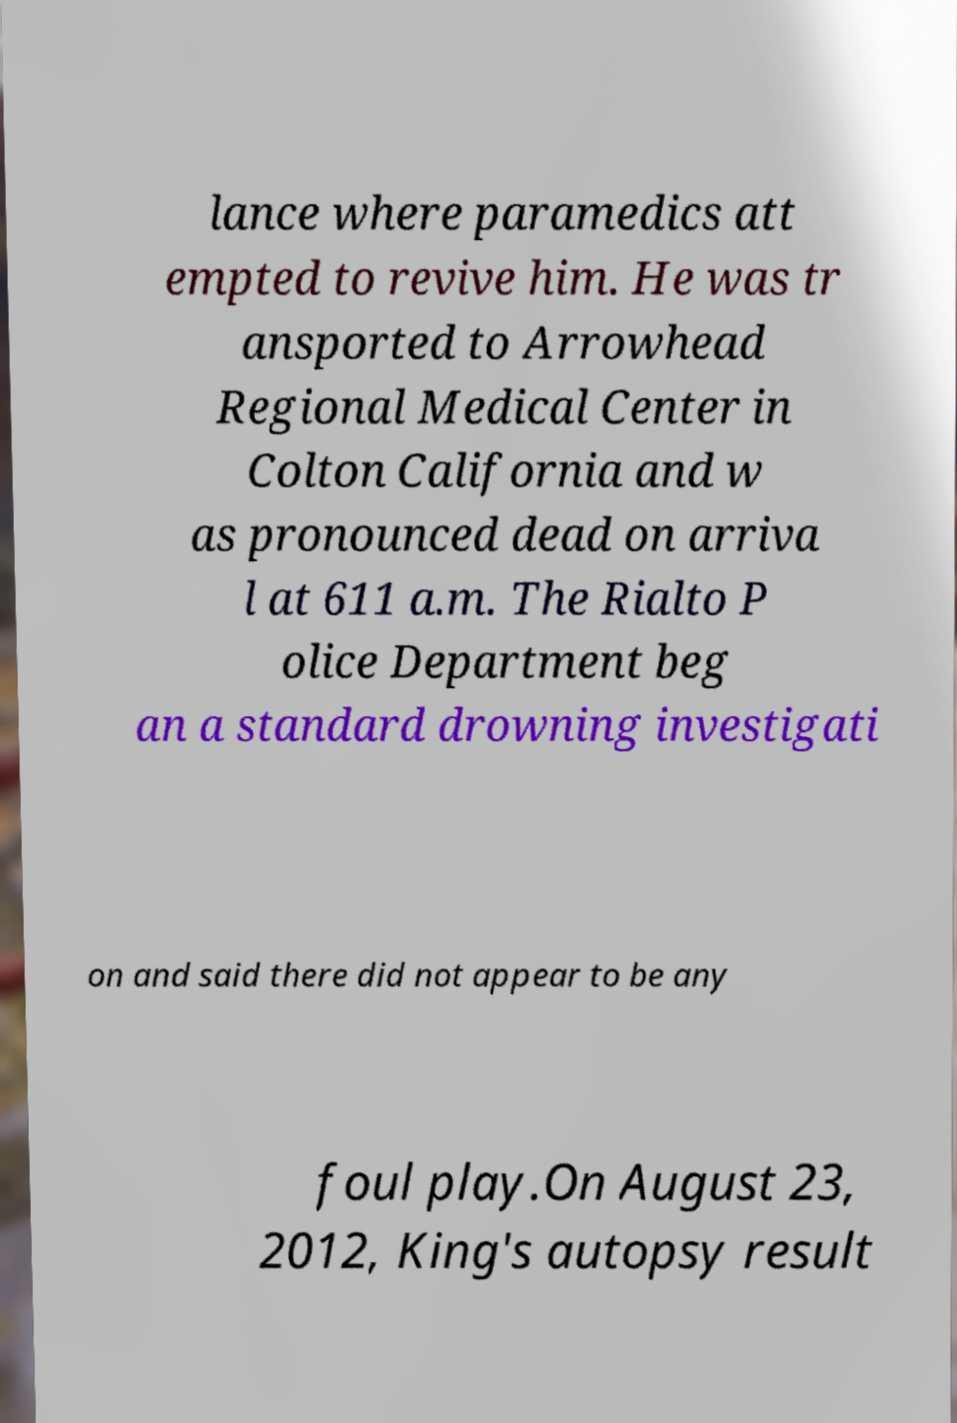Can you read and provide the text displayed in the image?This photo seems to have some interesting text. Can you extract and type it out for me? lance where paramedics att empted to revive him. He was tr ansported to Arrowhead Regional Medical Center in Colton California and w as pronounced dead on arriva l at 611 a.m. The Rialto P olice Department beg an a standard drowning investigati on and said there did not appear to be any foul play.On August 23, 2012, King's autopsy result 